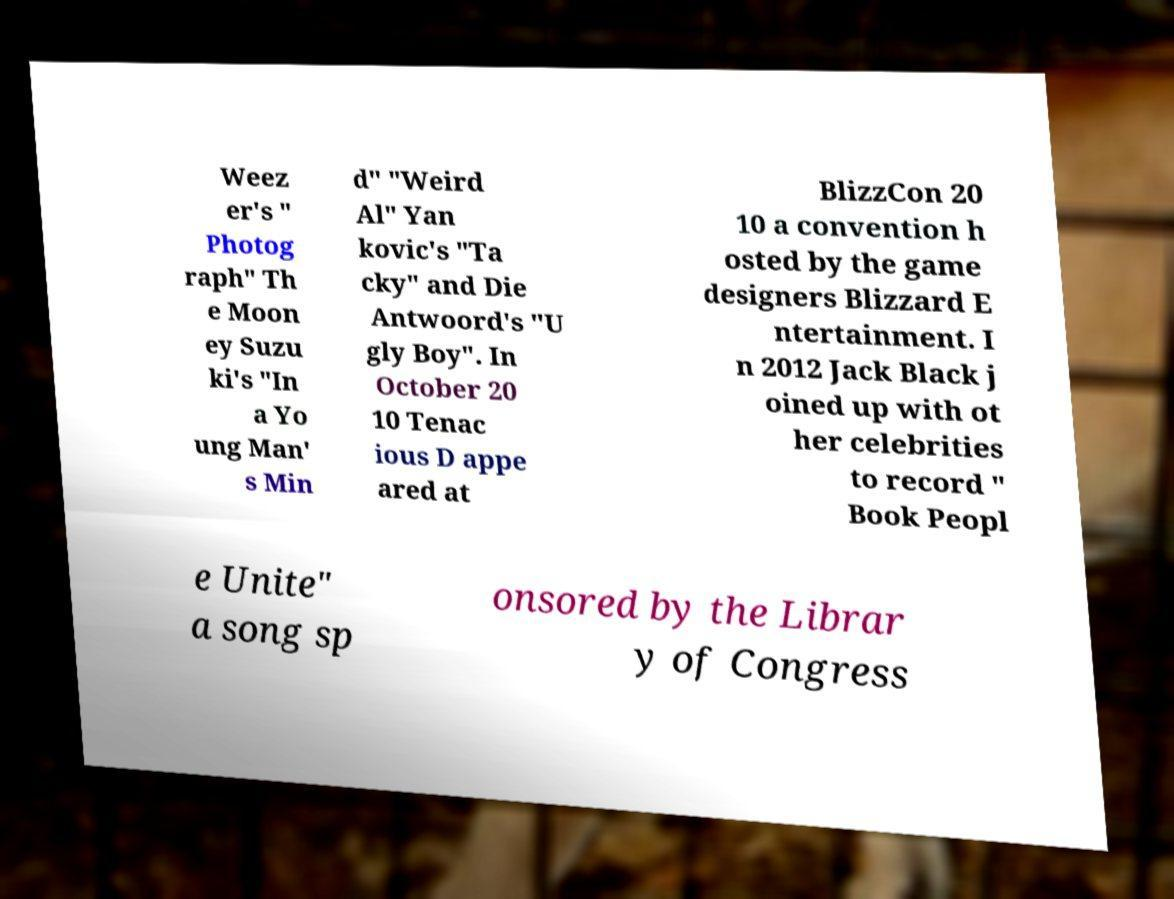What messages or text are displayed in this image? I need them in a readable, typed format. Weez er's " Photog raph" Th e Moon ey Suzu ki's "In a Yo ung Man' s Min d" "Weird Al" Yan kovic's "Ta cky" and Die Antwoord's "U gly Boy". In October 20 10 Tenac ious D appe ared at BlizzCon 20 10 a convention h osted by the game designers Blizzard E ntertainment. I n 2012 Jack Black j oined up with ot her celebrities to record " Book Peopl e Unite" a song sp onsored by the Librar y of Congress 